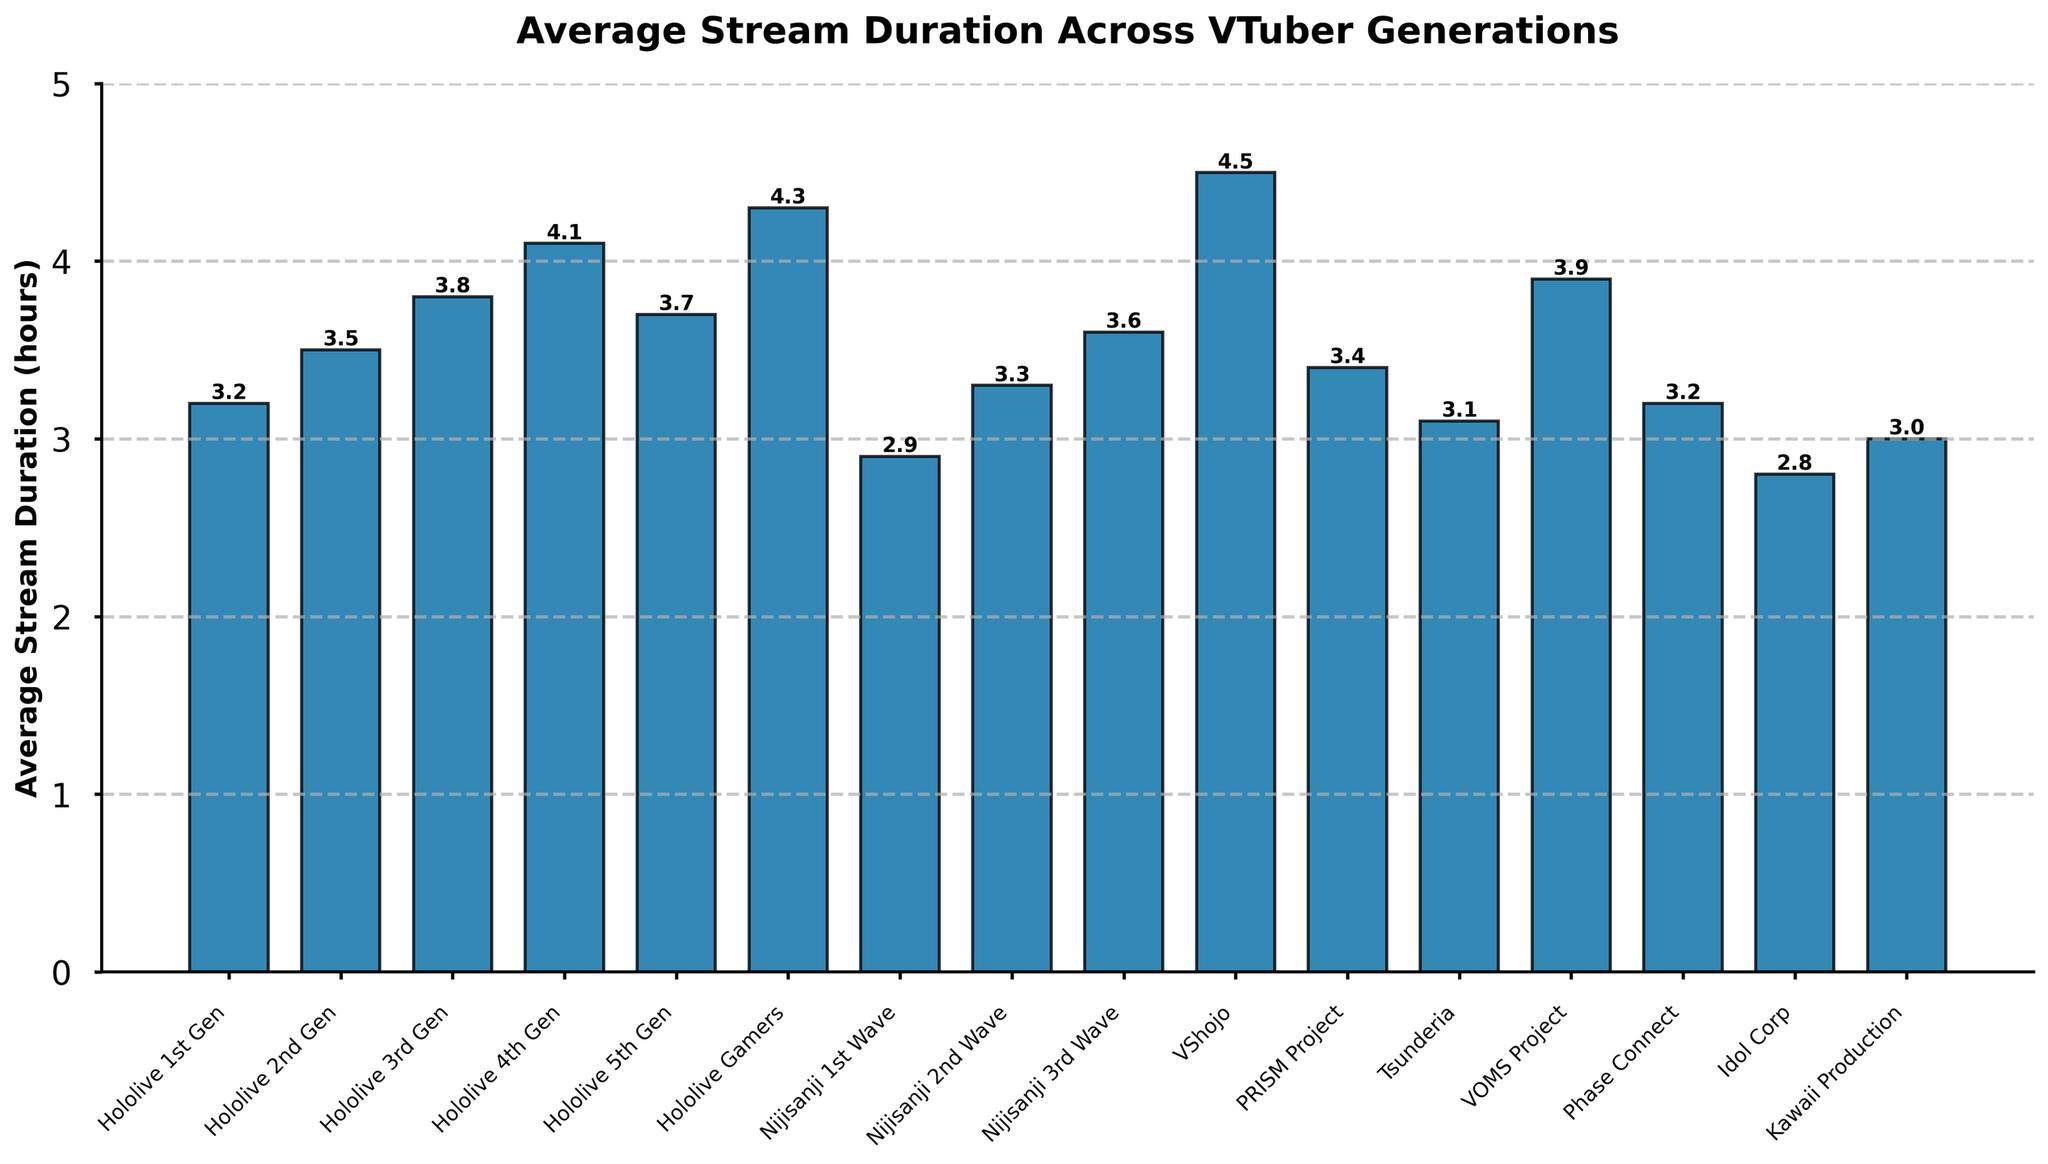What's the average stream duration for Hololive 4th Gen? Look for the bar labeled "Hololive 4th Gen" and read its height.
Answer: 4.1 hours Which generation has the highest average stream duration? Identify the tallest bar in the chart, which represents the highest average stream duration.
Answer: VShojo Is the average stream duration of Nijisanji 1st Wave greater than that of Hololive 1st Gen? Compare the height of the bars for "Nijisanji 1st Wave" and "Hololive 1st Gen." The "Nijisanji 1st Wave" bar is shorter than the "Hololive 1st Gen" bar.
Answer: No What is the combined average stream duration of Hololive 2nd Gen and Hololive 3rd Gen? Find the values for "Hololive 2nd Gen" and "Hololive 3rd Gen" and add them together: 3.5 + 3.8.
Answer: 7.3 hours Which has a greater average stream duration: PRISM Project or Tsunderia? Compare the heights of the "PRISM Project" and "Tsunderia" bars. "PRISM Project" is taller.
Answer: PRISM Project What is the difference in average stream duration between VShojo and Idol Corp? Subtract the average stream duration of "Idol Corp" from that of "VShojo": 4.5 - 2.8.
Answer: 1.7 hours How many generations have an average stream duration of 4 hours or more? Count the bars that reach or exceed the 4-hour mark.
Answer: 3 What is the median average stream duration of all generations represented? List all durations: [3.2, 3.5, 3.8, 4.1, 3.7, 4.3, 2.9, 3.3, 3.6, 4.5, 3.4, 3.1, 3.9, 3.2, 2.8, 3.0], sort them, and find the middle value(s): (3.3 + 3.4)/2.
Answer: 3.35 hours Which generation has the lowest average stream duration? Identify the shortest bar in the chart, which represents the lowest average stream duration.
Answer: Idol Corp 